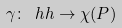<formula> <loc_0><loc_0><loc_500><loc_500>\gamma \colon \ h h \to \chi ( P )</formula> 